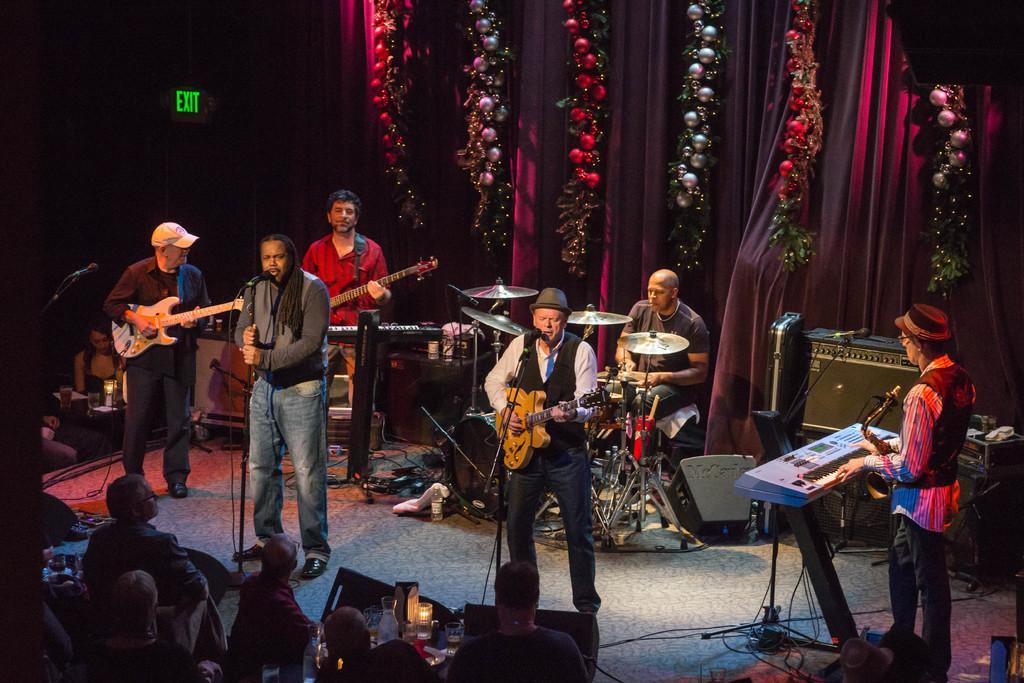Can you describe this image briefly? In this image we can see a few people, some of them are on the stage, three persons are playing guitar, one person is playing the keyboard, another person is playing jazz, there are some mics, wires connected to musical instruments, also we can see some electronic objects, we can see lights, decorative items, curtains, exit board, and a person is singing. 